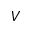Convert formula to latex. <formula><loc_0><loc_0><loc_500><loc_500>V</formula> 